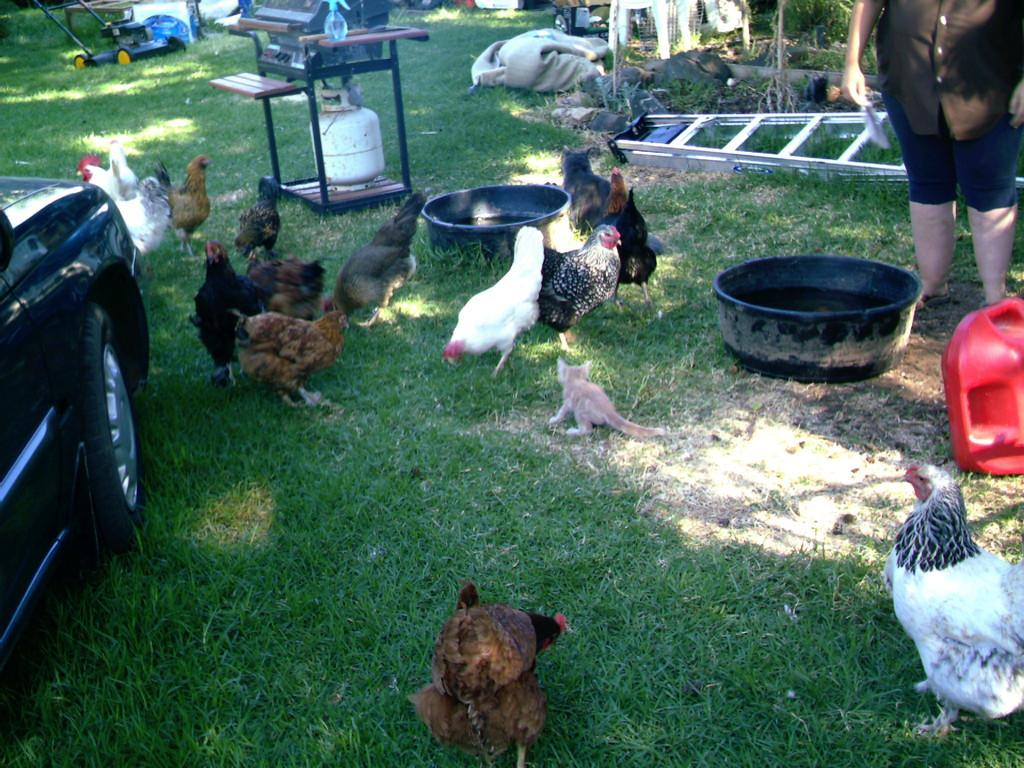What type of animals can be seen in the image? Birds can be seen in the image. What other living creature is present in the image? There is a cat in the image. What type of tool is visible in the image? There is a grass cutter in the image. What is the person standing on the ground doing? The person's actions are not specified, but they are standing on the ground in the image. What is the stand with a cylinder used for? The purpose of the stand with a cylinder is not specified in the facts. What type of boundary can be seen in the image? There is no boundary present in the image. What part of the car is visible in the image? The facts do not specify which part of the car is visible in the image. 